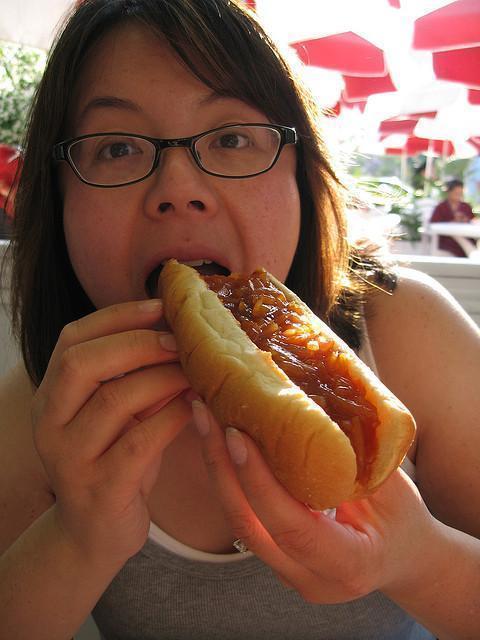What food is that bun normally used for?
Answer the question by selecting the correct answer among the 4 following choices.
Options: French fries, chicken strips, hot dogs, hamburgers. Hot dogs. 